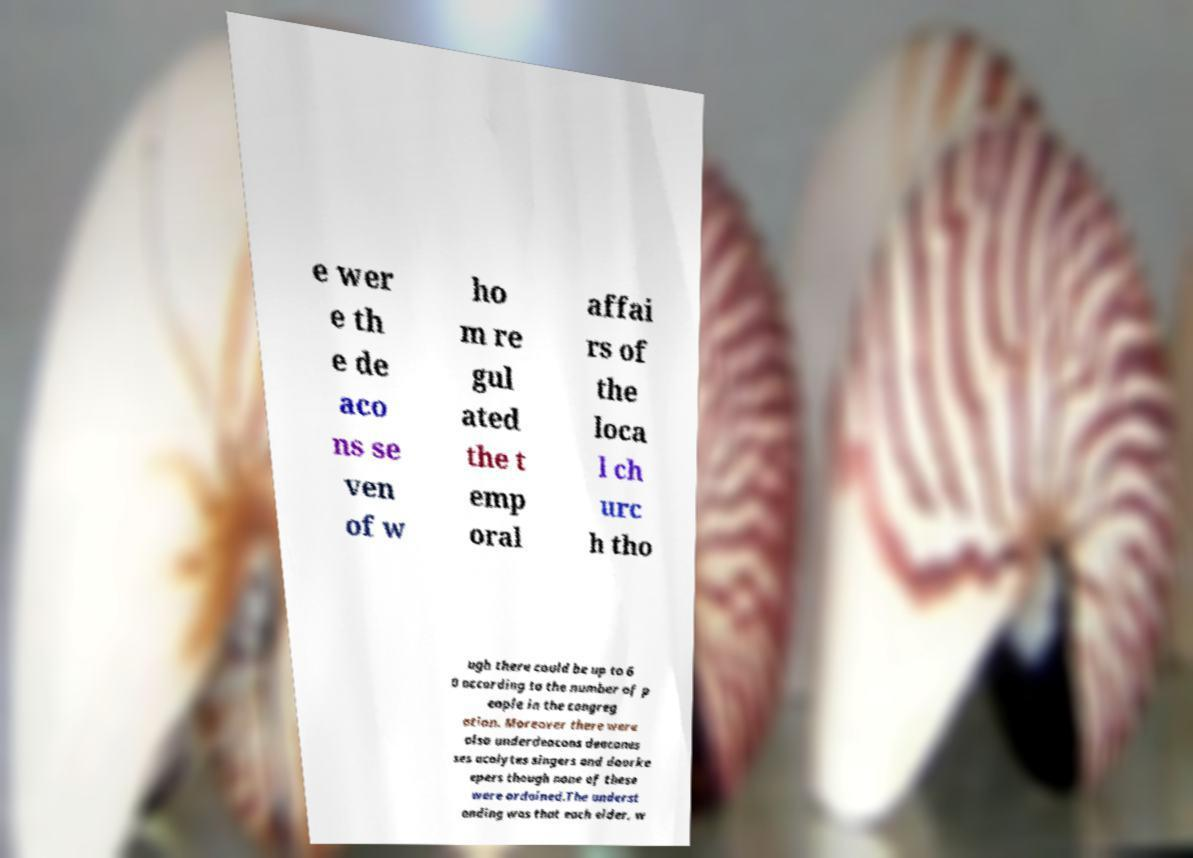Can you read and provide the text displayed in the image?This photo seems to have some interesting text. Can you extract and type it out for me? e wer e th e de aco ns se ven of w ho m re gul ated the t emp oral affai rs of the loca l ch urc h tho ugh there could be up to 6 0 according to the number of p eople in the congreg ation. Moreover there were also underdeacons deacones ses acolytes singers and doorke epers though none of these were ordained.The underst anding was that each elder, w 